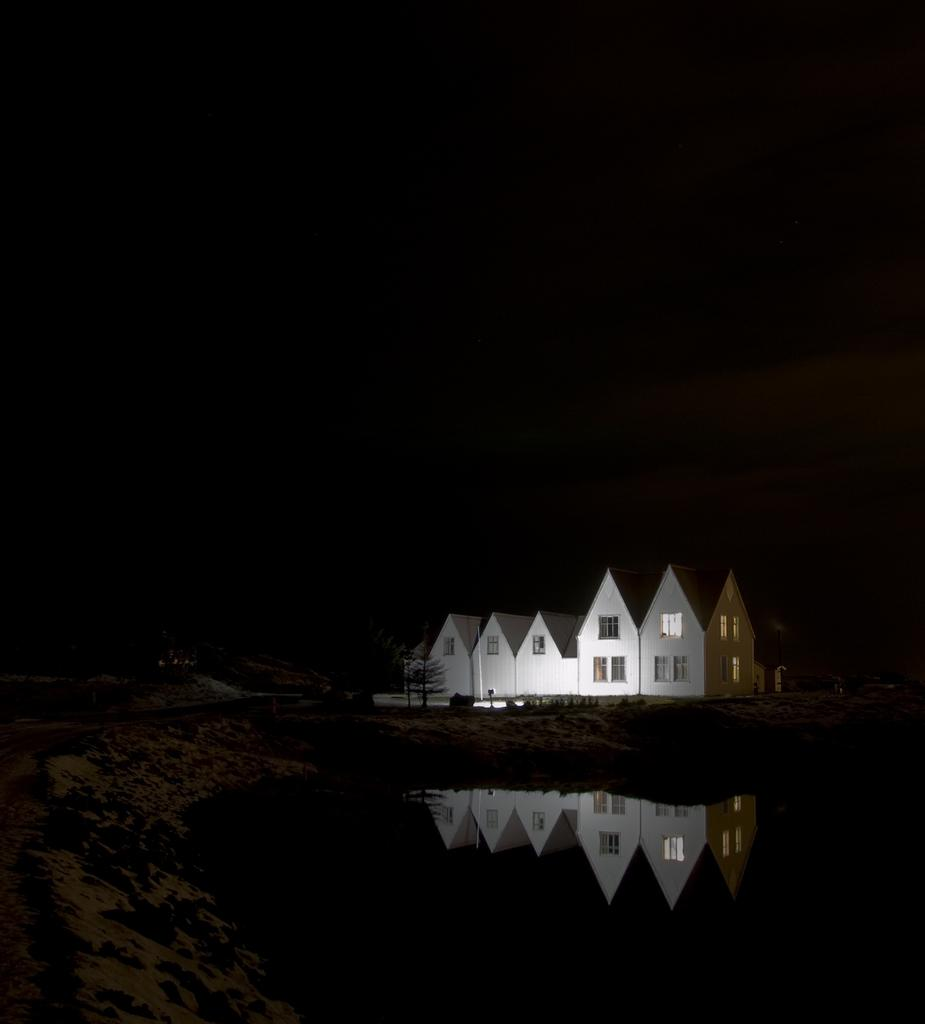What type of structures can be seen in the image? There are houses in the image. What other natural elements are present in the image? There are trees and water visible in the image. How would you describe the overall lighting in the image? The background of the image is dark. Can you tell me where the partner is located in the image? There is no partner present in the image. What type of animals can be seen at the zoo in the image? There is no zoo present in the image. 